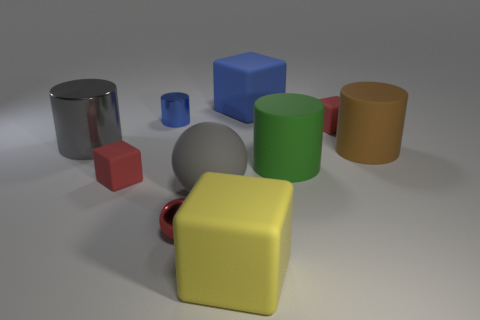How many objects are there in the image? There are a total of nine objects visible in the image.  Can you describe the shapes of these objects? Certainly! The objects include a combination of geometric shapes: there are three cylinders, two cubes, a sphere, and three cuboids of different dimensions. 